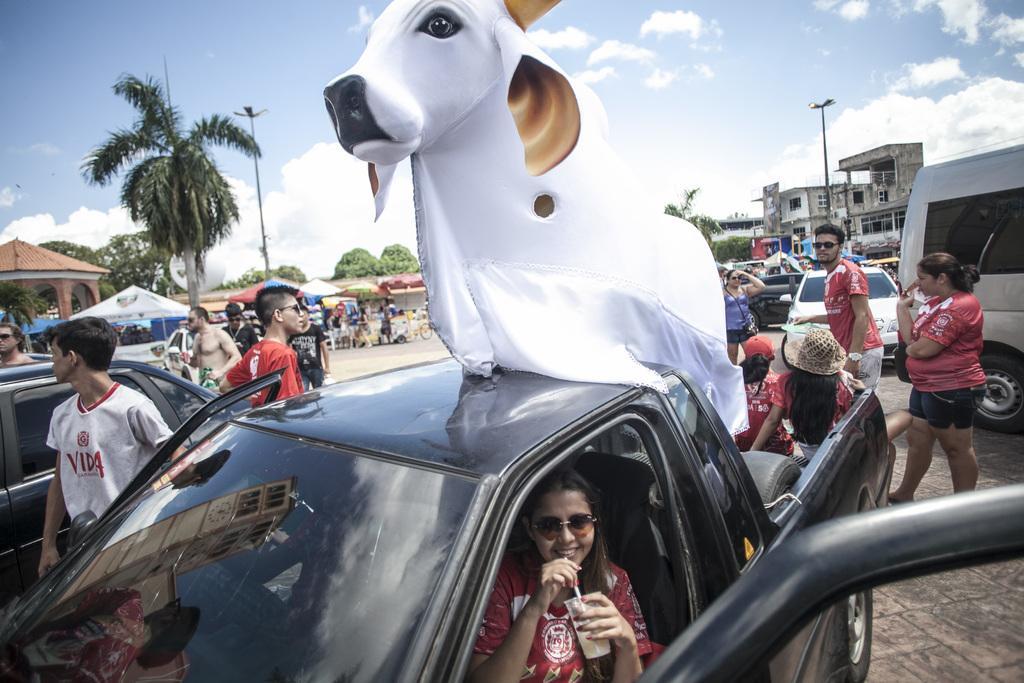In one or two sentences, can you explain what this image depicts? This image is clicked on the road. There are many vehicles on the road. There are people walking on the road. In the foreground there is a car. There is a girl sitting in the car and holding a glass in her hand. In the boot there is a model of a cow. In the background there are buildings, trees, street light poles, table umbrellas and chairs. At the top there is the sky. There are clouds in the sky. 